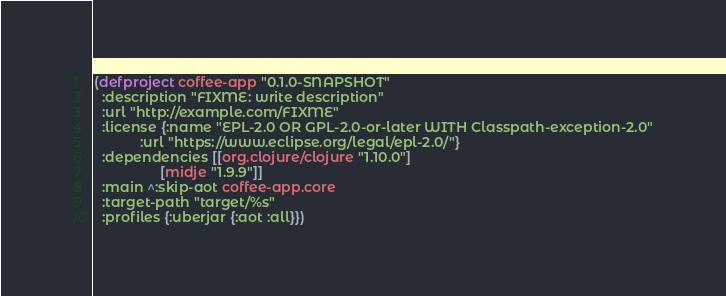<code> <loc_0><loc_0><loc_500><loc_500><_Clojure_>(defproject coffee-app "0.1.0-SNAPSHOT"
  :description "FIXME: write description"
  :url "http://example.com/FIXME"
  :license {:name "EPL-2.0 OR GPL-2.0-or-later WITH Classpath-exception-2.0"
            :url "https://www.eclipse.org/legal/epl-2.0/"}
  :dependencies [[org.clojure/clojure "1.10.0"]
                 [midje "1.9.9"]]
  :main ^:skip-aot coffee-app.core
  :target-path "target/%s"
  :profiles {:uberjar {:aot :all}})
</code> 